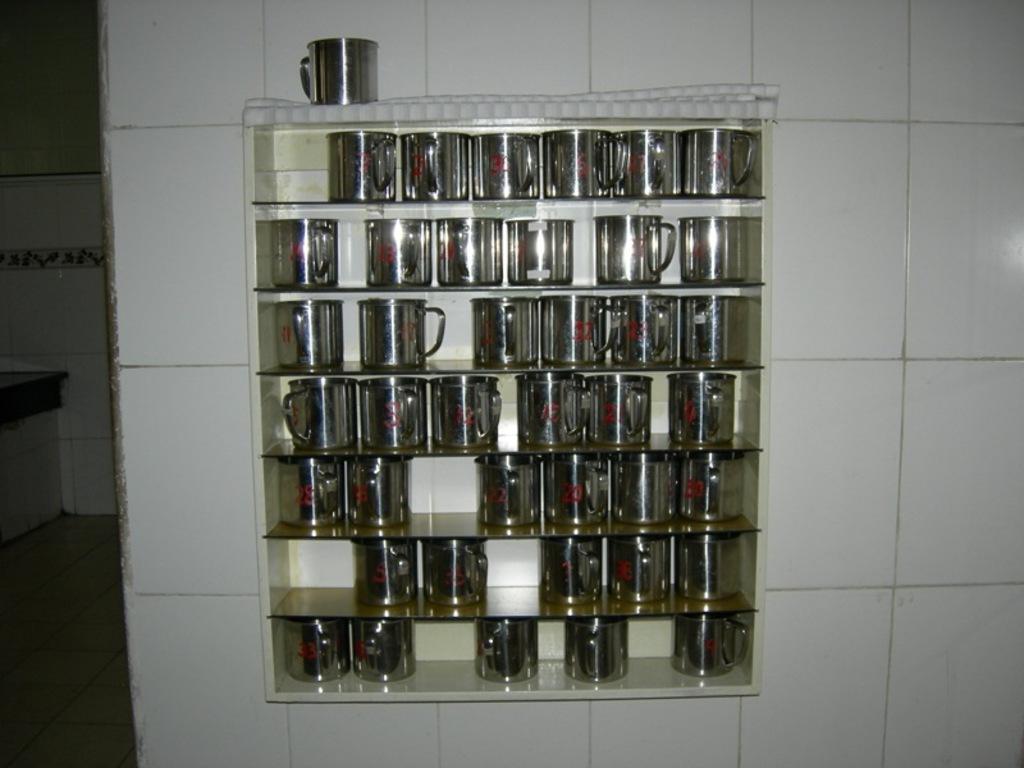Could you give a brief overview of what you see in this image? This image consists of cups kept in a rack. In the background, there is a wall on which we can see the tiles in white color. 